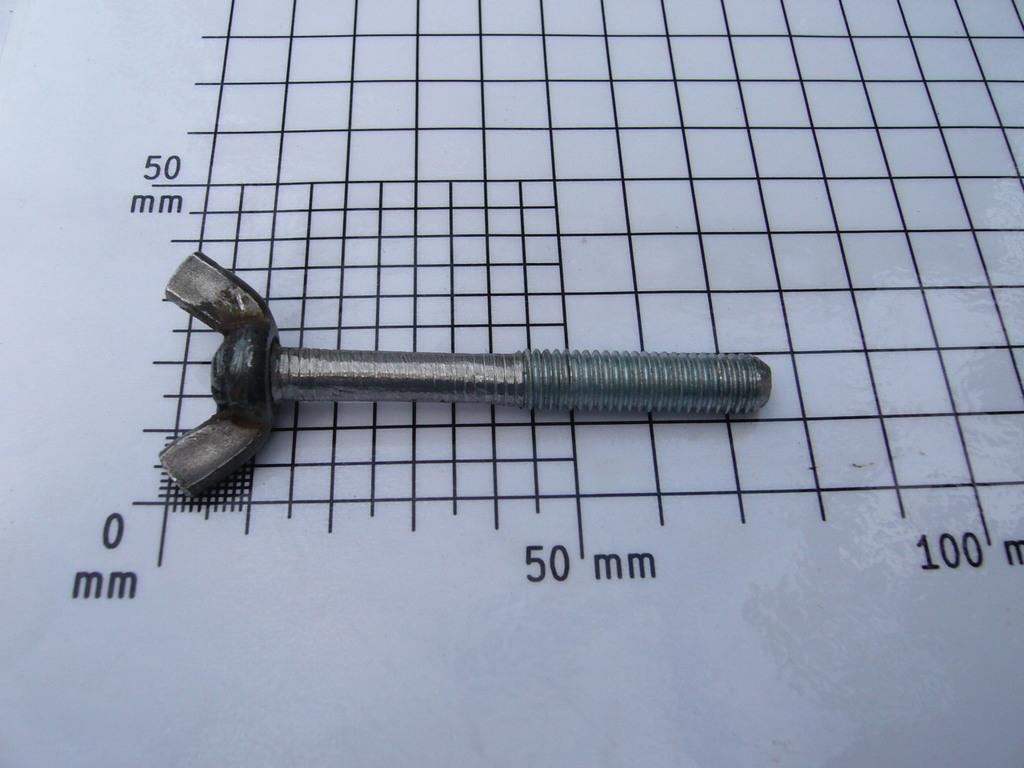<image>
Offer a succinct explanation of the picture presented. A wing nut screw measures between 50 and 100 mm. 